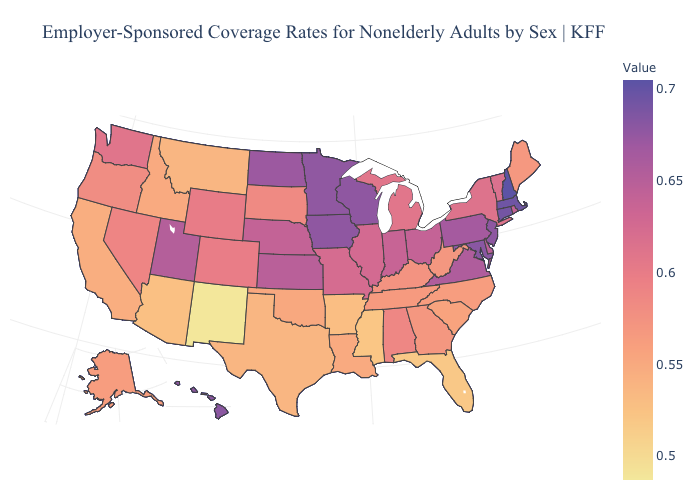Does Wisconsin have a higher value than New Hampshire?
Concise answer only. No. Does Maryland have the highest value in the South?
Write a very short answer. Yes. Among the states that border Texas , does Oklahoma have the lowest value?
Answer briefly. No. Does Virginia have a lower value than Texas?
Concise answer only. No. Does Alabama have the highest value in the South?
Quick response, please. No. Among the states that border Arizona , does New Mexico have the lowest value?
Answer briefly. Yes. 